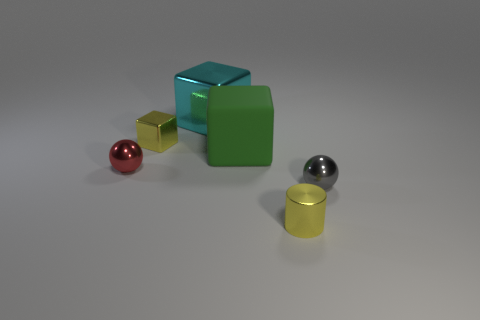Add 3 tiny red spheres. How many objects exist? 9 Subtract all cylinders. How many objects are left? 5 Add 3 cyan metallic objects. How many cyan metallic objects exist? 4 Subtract 0 brown blocks. How many objects are left? 6 Subtract all cyan metal objects. Subtract all yellow objects. How many objects are left? 3 Add 3 rubber objects. How many rubber objects are left? 4 